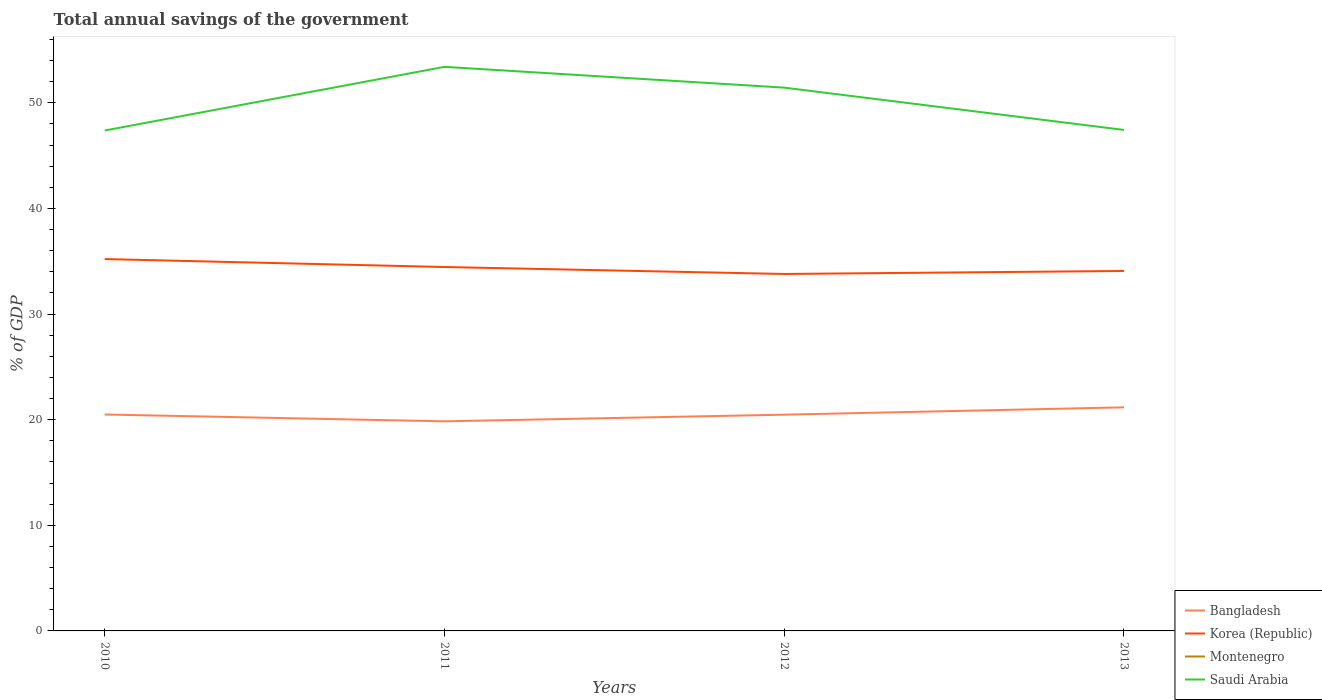How many different coloured lines are there?
Your answer should be very brief. 3. Across all years, what is the maximum total annual savings of the government in Korea (Republic)?
Your answer should be very brief. 33.8. What is the total total annual savings of the government in Saudi Arabia in the graph?
Provide a succinct answer. -6.03. What is the difference between the highest and the second highest total annual savings of the government in Saudi Arabia?
Keep it short and to the point. 6.03. What is the difference between the highest and the lowest total annual savings of the government in Saudi Arabia?
Offer a very short reply. 2. Is the total annual savings of the government in Bangladesh strictly greater than the total annual savings of the government in Saudi Arabia over the years?
Keep it short and to the point. Yes. How many years are there in the graph?
Your answer should be very brief. 4. What is the difference between two consecutive major ticks on the Y-axis?
Your answer should be very brief. 10. Are the values on the major ticks of Y-axis written in scientific E-notation?
Your answer should be compact. No. Does the graph contain grids?
Offer a terse response. No. Where does the legend appear in the graph?
Your answer should be very brief. Bottom right. How are the legend labels stacked?
Make the answer very short. Vertical. What is the title of the graph?
Offer a very short reply. Total annual savings of the government. What is the label or title of the X-axis?
Your response must be concise. Years. What is the label or title of the Y-axis?
Provide a succinct answer. % of GDP. What is the % of GDP of Bangladesh in 2010?
Provide a succinct answer. 20.49. What is the % of GDP of Korea (Republic) in 2010?
Your response must be concise. 35.21. What is the % of GDP in Saudi Arabia in 2010?
Your answer should be compact. 47.38. What is the % of GDP in Bangladesh in 2011?
Offer a terse response. 19.84. What is the % of GDP of Korea (Republic) in 2011?
Offer a terse response. 34.45. What is the % of GDP of Saudi Arabia in 2011?
Provide a short and direct response. 53.41. What is the % of GDP of Bangladesh in 2012?
Your response must be concise. 20.47. What is the % of GDP in Korea (Republic) in 2012?
Give a very brief answer. 33.8. What is the % of GDP of Saudi Arabia in 2012?
Offer a terse response. 51.44. What is the % of GDP of Bangladesh in 2013?
Your answer should be compact. 21.17. What is the % of GDP in Korea (Republic) in 2013?
Make the answer very short. 34.08. What is the % of GDP in Montenegro in 2013?
Offer a terse response. 0. What is the % of GDP in Saudi Arabia in 2013?
Your answer should be compact. 47.43. Across all years, what is the maximum % of GDP in Bangladesh?
Your response must be concise. 21.17. Across all years, what is the maximum % of GDP in Korea (Republic)?
Give a very brief answer. 35.21. Across all years, what is the maximum % of GDP of Saudi Arabia?
Your answer should be very brief. 53.41. Across all years, what is the minimum % of GDP in Bangladesh?
Offer a very short reply. 19.84. Across all years, what is the minimum % of GDP in Korea (Republic)?
Your answer should be very brief. 33.8. Across all years, what is the minimum % of GDP of Saudi Arabia?
Give a very brief answer. 47.38. What is the total % of GDP in Bangladesh in the graph?
Make the answer very short. 81.98. What is the total % of GDP in Korea (Republic) in the graph?
Your response must be concise. 137.54. What is the total % of GDP in Saudi Arabia in the graph?
Your answer should be compact. 199.65. What is the difference between the % of GDP in Bangladesh in 2010 and that in 2011?
Offer a very short reply. 0.65. What is the difference between the % of GDP of Korea (Republic) in 2010 and that in 2011?
Provide a succinct answer. 0.75. What is the difference between the % of GDP in Saudi Arabia in 2010 and that in 2011?
Provide a short and direct response. -6.03. What is the difference between the % of GDP of Bangladesh in 2010 and that in 2012?
Your answer should be compact. 0.02. What is the difference between the % of GDP in Korea (Republic) in 2010 and that in 2012?
Provide a succinct answer. 1.41. What is the difference between the % of GDP in Saudi Arabia in 2010 and that in 2012?
Give a very brief answer. -4.06. What is the difference between the % of GDP of Bangladesh in 2010 and that in 2013?
Ensure brevity in your answer.  -0.68. What is the difference between the % of GDP of Korea (Republic) in 2010 and that in 2013?
Keep it short and to the point. 1.13. What is the difference between the % of GDP in Saudi Arabia in 2010 and that in 2013?
Make the answer very short. -0.06. What is the difference between the % of GDP in Bangladesh in 2011 and that in 2012?
Provide a succinct answer. -0.63. What is the difference between the % of GDP of Korea (Republic) in 2011 and that in 2012?
Make the answer very short. 0.66. What is the difference between the % of GDP of Saudi Arabia in 2011 and that in 2012?
Your answer should be very brief. 1.97. What is the difference between the % of GDP of Bangladesh in 2011 and that in 2013?
Offer a very short reply. -1.32. What is the difference between the % of GDP in Korea (Republic) in 2011 and that in 2013?
Ensure brevity in your answer.  0.37. What is the difference between the % of GDP of Saudi Arabia in 2011 and that in 2013?
Make the answer very short. 5.97. What is the difference between the % of GDP of Bangladesh in 2012 and that in 2013?
Ensure brevity in your answer.  -0.69. What is the difference between the % of GDP in Korea (Republic) in 2012 and that in 2013?
Ensure brevity in your answer.  -0.29. What is the difference between the % of GDP of Saudi Arabia in 2012 and that in 2013?
Offer a terse response. 4. What is the difference between the % of GDP of Bangladesh in 2010 and the % of GDP of Korea (Republic) in 2011?
Your answer should be compact. -13.96. What is the difference between the % of GDP in Bangladesh in 2010 and the % of GDP in Saudi Arabia in 2011?
Your answer should be very brief. -32.91. What is the difference between the % of GDP of Korea (Republic) in 2010 and the % of GDP of Saudi Arabia in 2011?
Provide a succinct answer. -18.2. What is the difference between the % of GDP in Bangladesh in 2010 and the % of GDP in Korea (Republic) in 2012?
Offer a terse response. -13.3. What is the difference between the % of GDP in Bangladesh in 2010 and the % of GDP in Saudi Arabia in 2012?
Offer a very short reply. -30.95. What is the difference between the % of GDP of Korea (Republic) in 2010 and the % of GDP of Saudi Arabia in 2012?
Your answer should be very brief. -16.23. What is the difference between the % of GDP of Bangladesh in 2010 and the % of GDP of Korea (Republic) in 2013?
Your response must be concise. -13.59. What is the difference between the % of GDP in Bangladesh in 2010 and the % of GDP in Saudi Arabia in 2013?
Your answer should be compact. -26.94. What is the difference between the % of GDP in Korea (Republic) in 2010 and the % of GDP in Saudi Arabia in 2013?
Give a very brief answer. -12.23. What is the difference between the % of GDP in Bangladesh in 2011 and the % of GDP in Korea (Republic) in 2012?
Your answer should be very brief. -13.95. What is the difference between the % of GDP of Bangladesh in 2011 and the % of GDP of Saudi Arabia in 2012?
Provide a short and direct response. -31.59. What is the difference between the % of GDP in Korea (Republic) in 2011 and the % of GDP in Saudi Arabia in 2012?
Offer a very short reply. -16.98. What is the difference between the % of GDP of Bangladesh in 2011 and the % of GDP of Korea (Republic) in 2013?
Offer a very short reply. -14.24. What is the difference between the % of GDP in Bangladesh in 2011 and the % of GDP in Saudi Arabia in 2013?
Offer a very short reply. -27.59. What is the difference between the % of GDP in Korea (Republic) in 2011 and the % of GDP in Saudi Arabia in 2013?
Your response must be concise. -12.98. What is the difference between the % of GDP in Bangladesh in 2012 and the % of GDP in Korea (Republic) in 2013?
Ensure brevity in your answer.  -13.61. What is the difference between the % of GDP in Bangladesh in 2012 and the % of GDP in Saudi Arabia in 2013?
Provide a short and direct response. -26.96. What is the difference between the % of GDP in Korea (Republic) in 2012 and the % of GDP in Saudi Arabia in 2013?
Make the answer very short. -13.64. What is the average % of GDP in Bangladesh per year?
Make the answer very short. 20.5. What is the average % of GDP of Korea (Republic) per year?
Offer a very short reply. 34.38. What is the average % of GDP of Saudi Arabia per year?
Keep it short and to the point. 49.91. In the year 2010, what is the difference between the % of GDP in Bangladesh and % of GDP in Korea (Republic)?
Make the answer very short. -14.72. In the year 2010, what is the difference between the % of GDP in Bangladesh and % of GDP in Saudi Arabia?
Provide a short and direct response. -26.89. In the year 2010, what is the difference between the % of GDP in Korea (Republic) and % of GDP in Saudi Arabia?
Offer a terse response. -12.17. In the year 2011, what is the difference between the % of GDP of Bangladesh and % of GDP of Korea (Republic)?
Provide a short and direct response. -14.61. In the year 2011, what is the difference between the % of GDP of Bangladesh and % of GDP of Saudi Arabia?
Your response must be concise. -33.56. In the year 2011, what is the difference between the % of GDP of Korea (Republic) and % of GDP of Saudi Arabia?
Keep it short and to the point. -18.95. In the year 2012, what is the difference between the % of GDP of Bangladesh and % of GDP of Korea (Republic)?
Your answer should be very brief. -13.32. In the year 2012, what is the difference between the % of GDP in Bangladesh and % of GDP in Saudi Arabia?
Keep it short and to the point. -30.96. In the year 2012, what is the difference between the % of GDP in Korea (Republic) and % of GDP in Saudi Arabia?
Keep it short and to the point. -17.64. In the year 2013, what is the difference between the % of GDP of Bangladesh and % of GDP of Korea (Republic)?
Provide a succinct answer. -12.91. In the year 2013, what is the difference between the % of GDP in Bangladesh and % of GDP in Saudi Arabia?
Ensure brevity in your answer.  -26.26. In the year 2013, what is the difference between the % of GDP in Korea (Republic) and % of GDP in Saudi Arabia?
Ensure brevity in your answer.  -13.35. What is the ratio of the % of GDP in Bangladesh in 2010 to that in 2011?
Your answer should be compact. 1.03. What is the ratio of the % of GDP in Korea (Republic) in 2010 to that in 2011?
Provide a succinct answer. 1.02. What is the ratio of the % of GDP of Saudi Arabia in 2010 to that in 2011?
Offer a very short reply. 0.89. What is the ratio of the % of GDP in Korea (Republic) in 2010 to that in 2012?
Make the answer very short. 1.04. What is the ratio of the % of GDP of Saudi Arabia in 2010 to that in 2012?
Make the answer very short. 0.92. What is the ratio of the % of GDP in Bangladesh in 2010 to that in 2013?
Your response must be concise. 0.97. What is the ratio of the % of GDP of Korea (Republic) in 2010 to that in 2013?
Your response must be concise. 1.03. What is the ratio of the % of GDP of Bangladesh in 2011 to that in 2012?
Keep it short and to the point. 0.97. What is the ratio of the % of GDP of Korea (Republic) in 2011 to that in 2012?
Keep it short and to the point. 1.02. What is the ratio of the % of GDP in Saudi Arabia in 2011 to that in 2012?
Keep it short and to the point. 1.04. What is the ratio of the % of GDP in Bangladesh in 2011 to that in 2013?
Ensure brevity in your answer.  0.94. What is the ratio of the % of GDP in Korea (Republic) in 2011 to that in 2013?
Provide a short and direct response. 1.01. What is the ratio of the % of GDP in Saudi Arabia in 2011 to that in 2013?
Make the answer very short. 1.13. What is the ratio of the % of GDP of Bangladesh in 2012 to that in 2013?
Keep it short and to the point. 0.97. What is the ratio of the % of GDP of Korea (Republic) in 2012 to that in 2013?
Provide a succinct answer. 0.99. What is the ratio of the % of GDP of Saudi Arabia in 2012 to that in 2013?
Provide a succinct answer. 1.08. What is the difference between the highest and the second highest % of GDP of Bangladesh?
Provide a succinct answer. 0.68. What is the difference between the highest and the second highest % of GDP of Korea (Republic)?
Give a very brief answer. 0.75. What is the difference between the highest and the second highest % of GDP in Saudi Arabia?
Ensure brevity in your answer.  1.97. What is the difference between the highest and the lowest % of GDP in Bangladesh?
Make the answer very short. 1.32. What is the difference between the highest and the lowest % of GDP of Korea (Republic)?
Your answer should be very brief. 1.41. What is the difference between the highest and the lowest % of GDP in Saudi Arabia?
Make the answer very short. 6.03. 